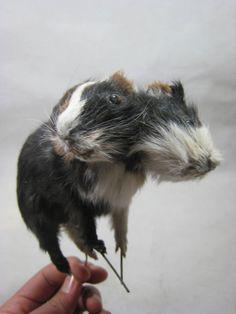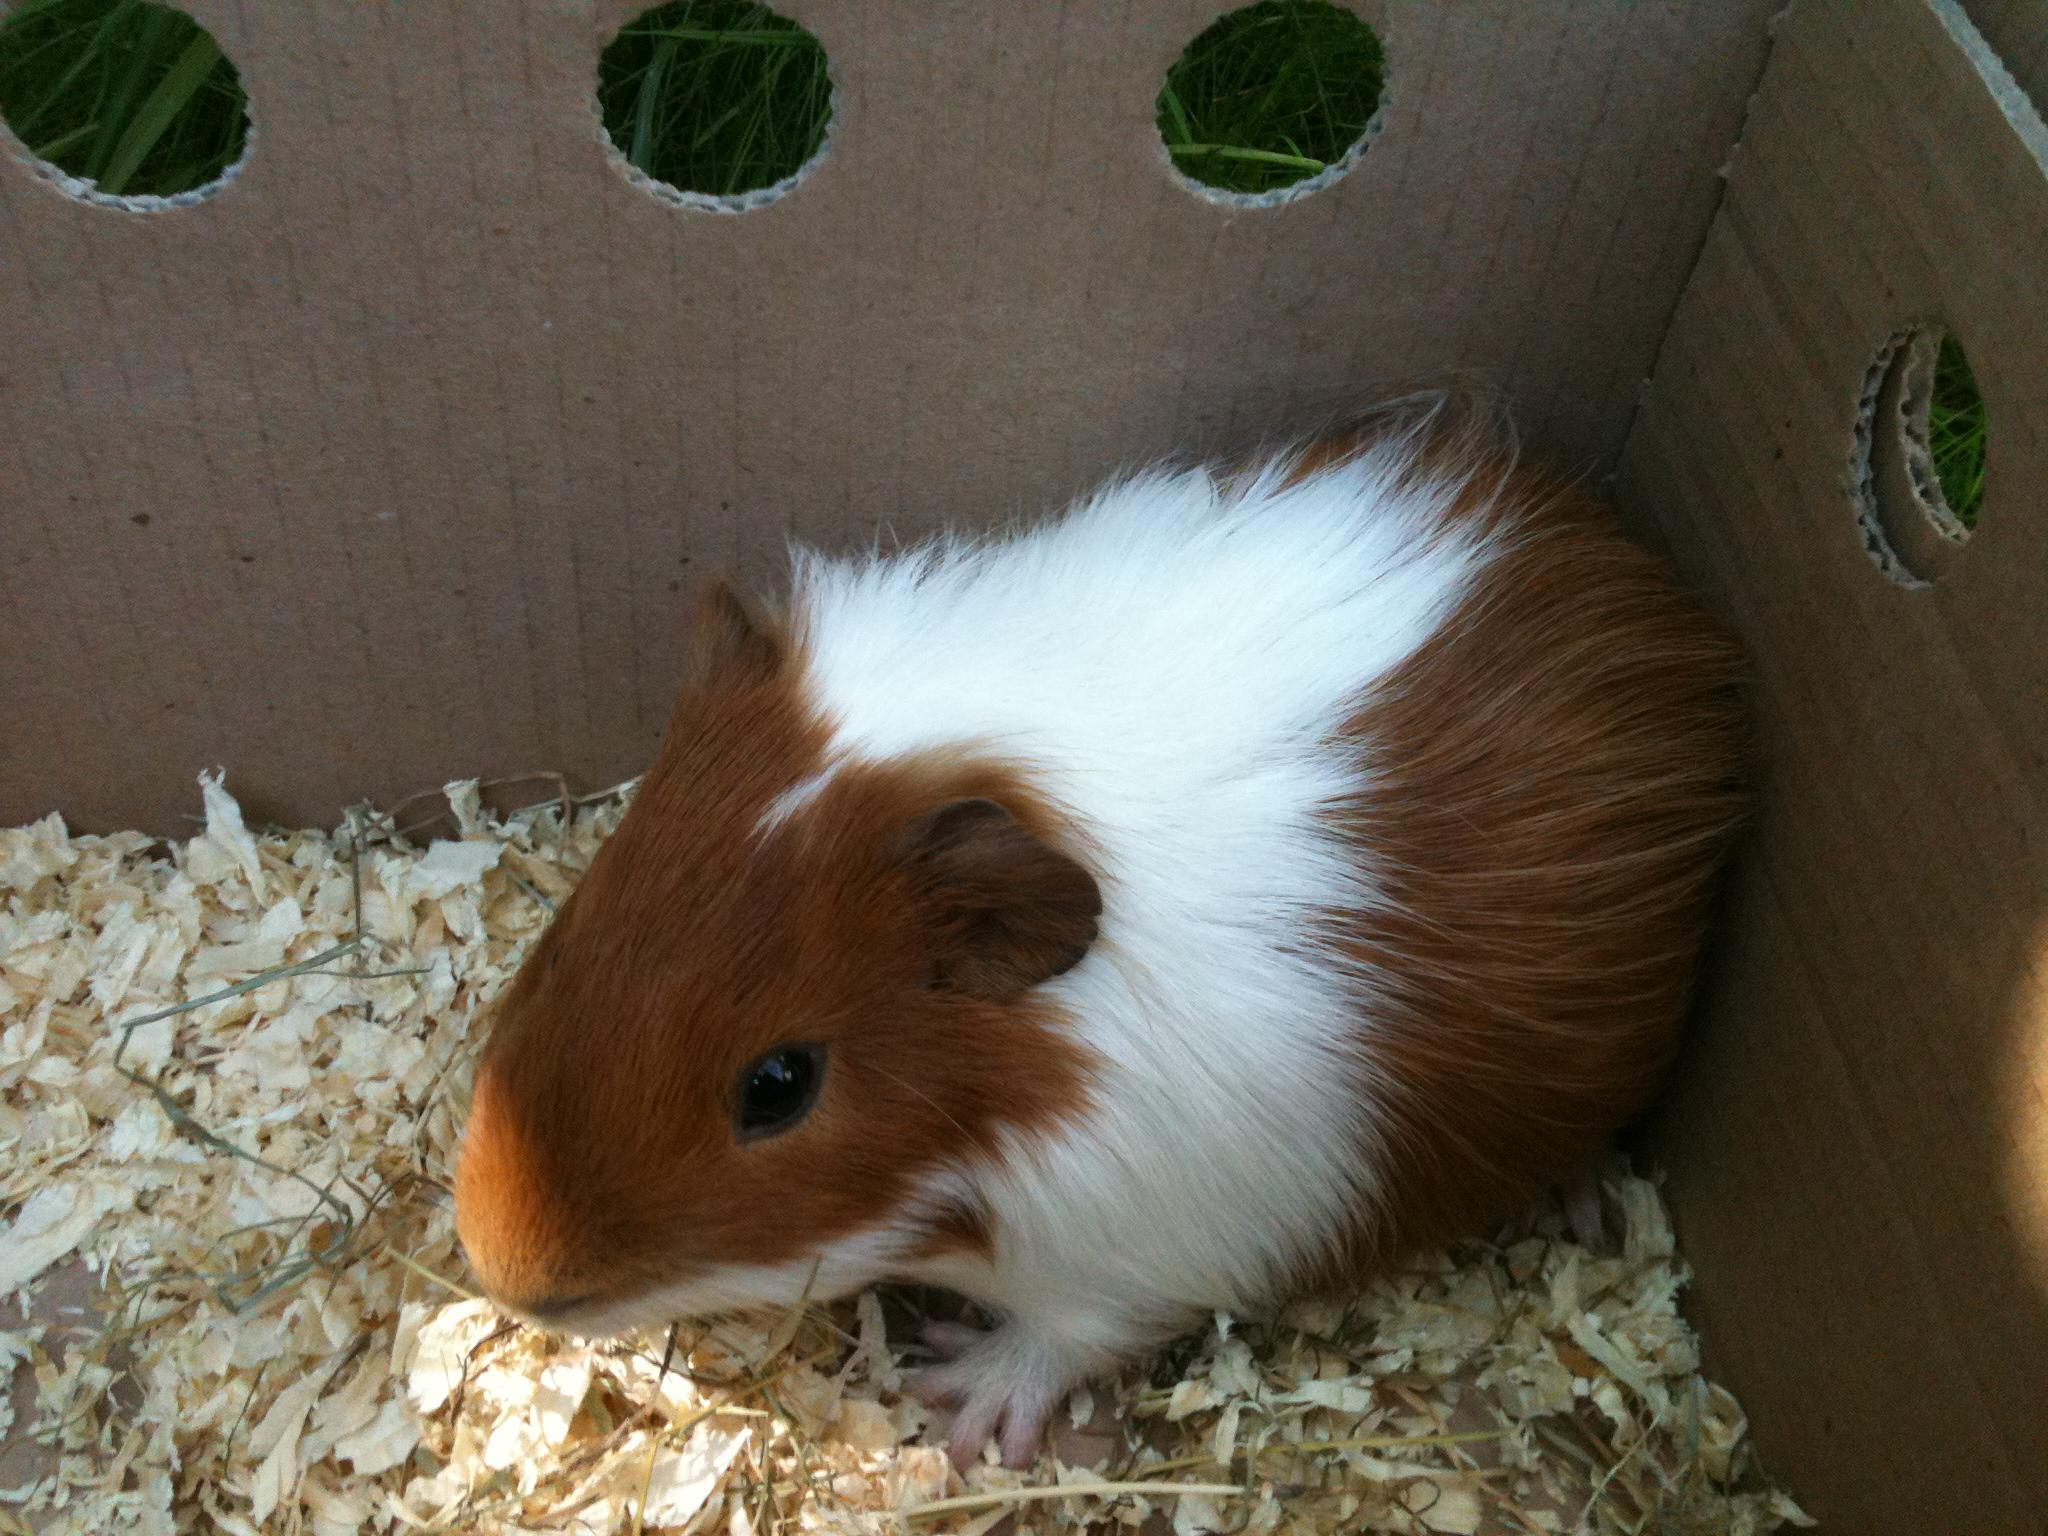The first image is the image on the left, the second image is the image on the right. For the images displayed, is the sentence "there is at least one guinea pig in a cardboard box" factually correct? Answer yes or no. Yes. The first image is the image on the left, the second image is the image on the right. For the images displayed, is the sentence "The right image has two guinea pigs." factually correct? Answer yes or no. No. 